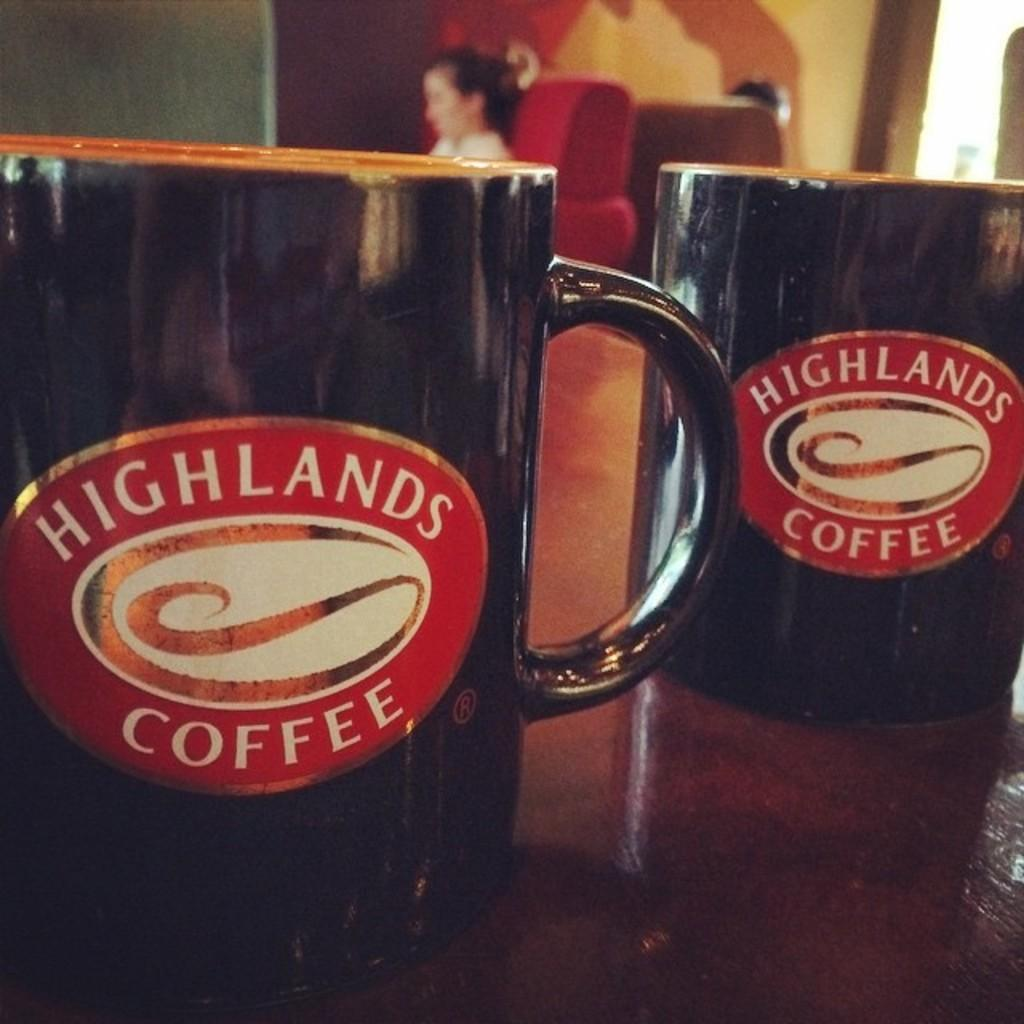<image>
Write a terse but informative summary of the picture. Two black coffee mugs that say Highlands Coffee. 